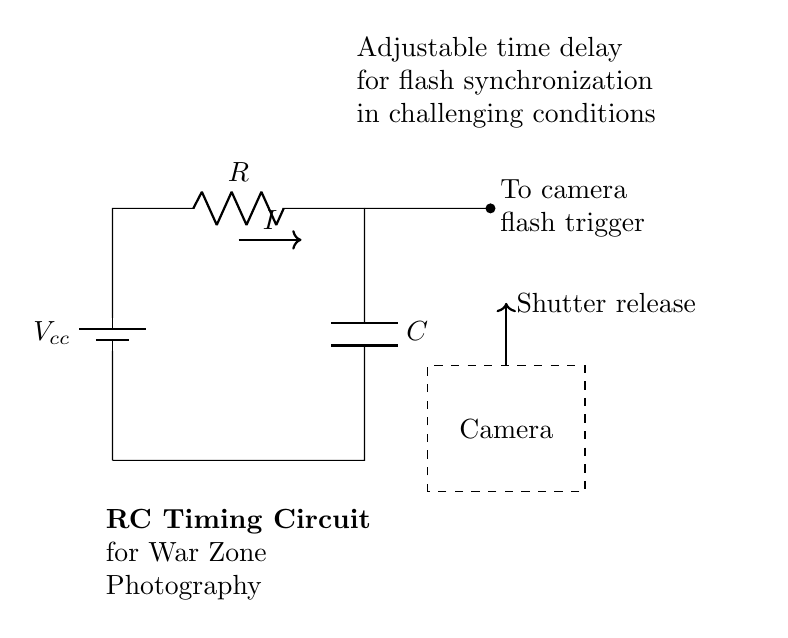What is the component labeled R? The component labeled R is a resistor, which is used to limit the current in the circuit.
Answer: Resistor What is the purpose of the capacitor in this circuit? The capacitor stores electrical energy and releases it to trigger the camera flash at a specific time, creating a delay set by the RC values.
Answer: Flash trigger What is the voltage source in this circuit? The circuit has a voltage source labeled Vcc, providing the necessary power for the operation of the circuit.
Answer: Vcc How does the current flow in the circuit? Current flows from the positive terminal of the voltage source, through the resistor, into the capacitor, and then out to the camera flash trigger.
Answer: From Vcc to flash trigger What is the function of the adjustable time delay in this RC circuit? The adjustable time delay allows for synchronization of the camera flash with the shutter release, which is crucial in varied lighting conditions in a war zone.
Answer: Synchronization of flash What happens to the capacitor when it charges? When the capacitor charges, it stores energy; once fully charged, it releases that energy to activate the flash, achieving a timed flash for photography.
Answer: Energy storage Is this circuit suitable for low-light conditions? Yes, this circuit is designed for low-light conditions as it offers flexibility in flash timing, essential for capturing moments in dark environments.
Answer: Yes 